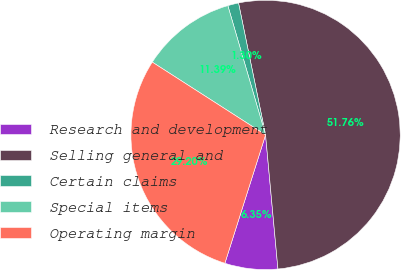Convert chart to OTSL. <chart><loc_0><loc_0><loc_500><loc_500><pie_chart><fcel>Research and development<fcel>Selling general and<fcel>Certain claims<fcel>Special items<fcel>Operating margin<nl><fcel>6.35%<fcel>51.75%<fcel>1.3%<fcel>11.39%<fcel>29.2%<nl></chart> 